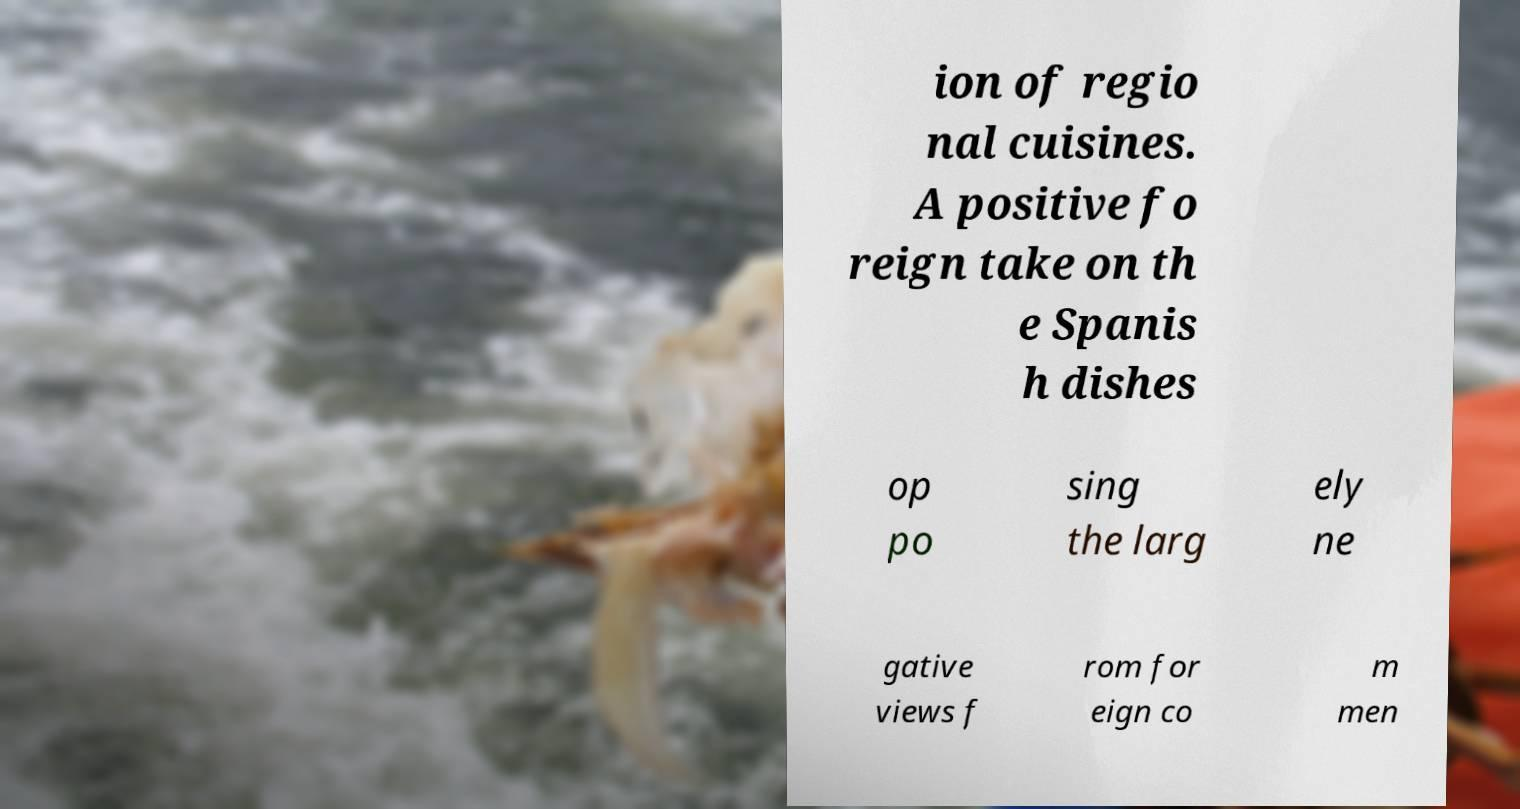Please read and relay the text visible in this image. What does it say? ion of regio nal cuisines. A positive fo reign take on th e Spanis h dishes op po sing the larg ely ne gative views f rom for eign co m men 